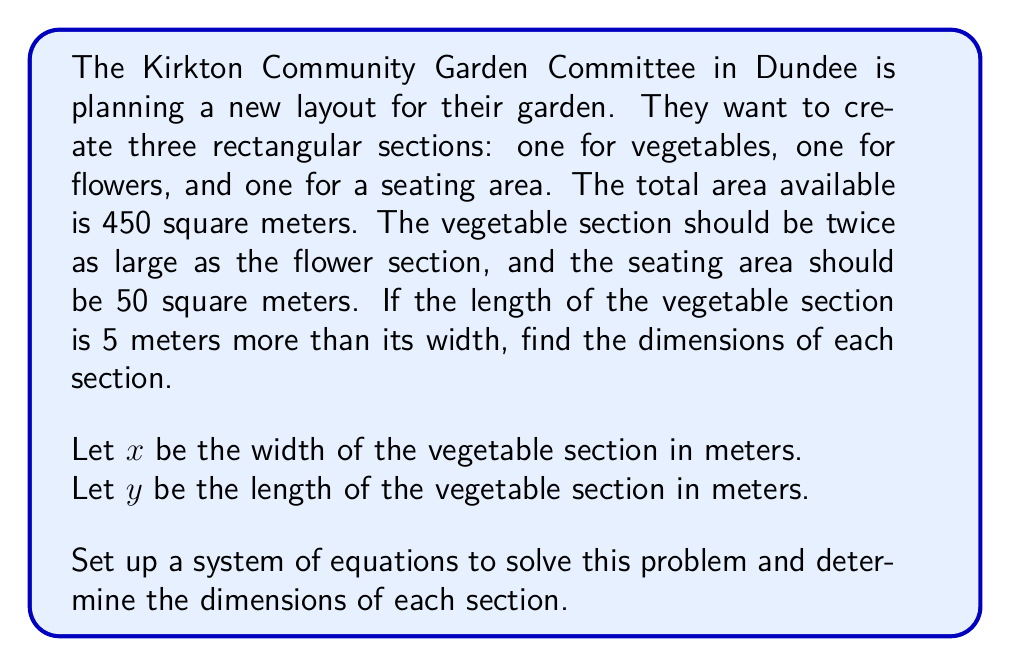Could you help me with this problem? Let's approach this step-by-step:

1) First, we can set up an equation based on the information about the vegetable section:
   $y = x + 5$ (length is 5 meters more than width)

2) We know the vegetable section should be twice as large as the flower section. If we call the area of the flower section $A_f$, then:
   $xy = 2A_f$

3) The total area is 450 square meters, and the seating area is 50 square meters. So:
   $xy + A_f + 50 = 450$

4) Substituting $xy = 2A_f$ from step 2 into this equation:
   $2A_f + A_f + 50 = 450$
   $3A_f = 400$
   $A_f = \frac{400}{3} \approx 133.33$ square meters

5) Now we can set up our system of equations:
   $$\begin{cases}
   y = x + 5 \\
   xy = 2(\frac{400}{3}) = \frac{800}{3}
   \end{cases}$$

6) Substituting the first equation into the second:
   $x(x+5) = \frac{800}{3}$
   $x^2 + 5x - \frac{800}{3} = 0$

7) This is a quadratic equation. We can solve it using the quadratic formula:
   $x = \frac{-b \pm \sqrt{b^2 - 4ac}}{2a}$

   Where $a=1$, $b=5$, and $c=-\frac{800}{3}$

8) Solving:
   $x = \frac{-5 \pm \sqrt{25 + \frac{3200}{3}}}{2} = \frac{-5 \pm \sqrt{\frac{3275}{3}}}{2}$

9) Taking the positive root (as width cannot be negative):
   $x \approx 13.33$ meters

10) Therefore, $y = x + 5 \approx 18.33$ meters

11) The flower section will have half the area of the vegetable section:
    $\frac{13.33 * 18.33}{2} \approx 122.17$ square meters

12) We can find the dimensions of the flower section by taking the square root:
    $\sqrt{122.17} \approx 11.05$ meters

Thus, the dimensions are:
- Vegetable section: 13.33 m x 18.33 m
- Flower section: 11.05 m x 11.05 m
- Seating area: Already given as 50 square meters
Answer: Vegetable section: 13.33 m x 18.33 m
Flower section: 11.05 m x 11.05 m
Seating area: 50 square meters (dimensions not specified) 